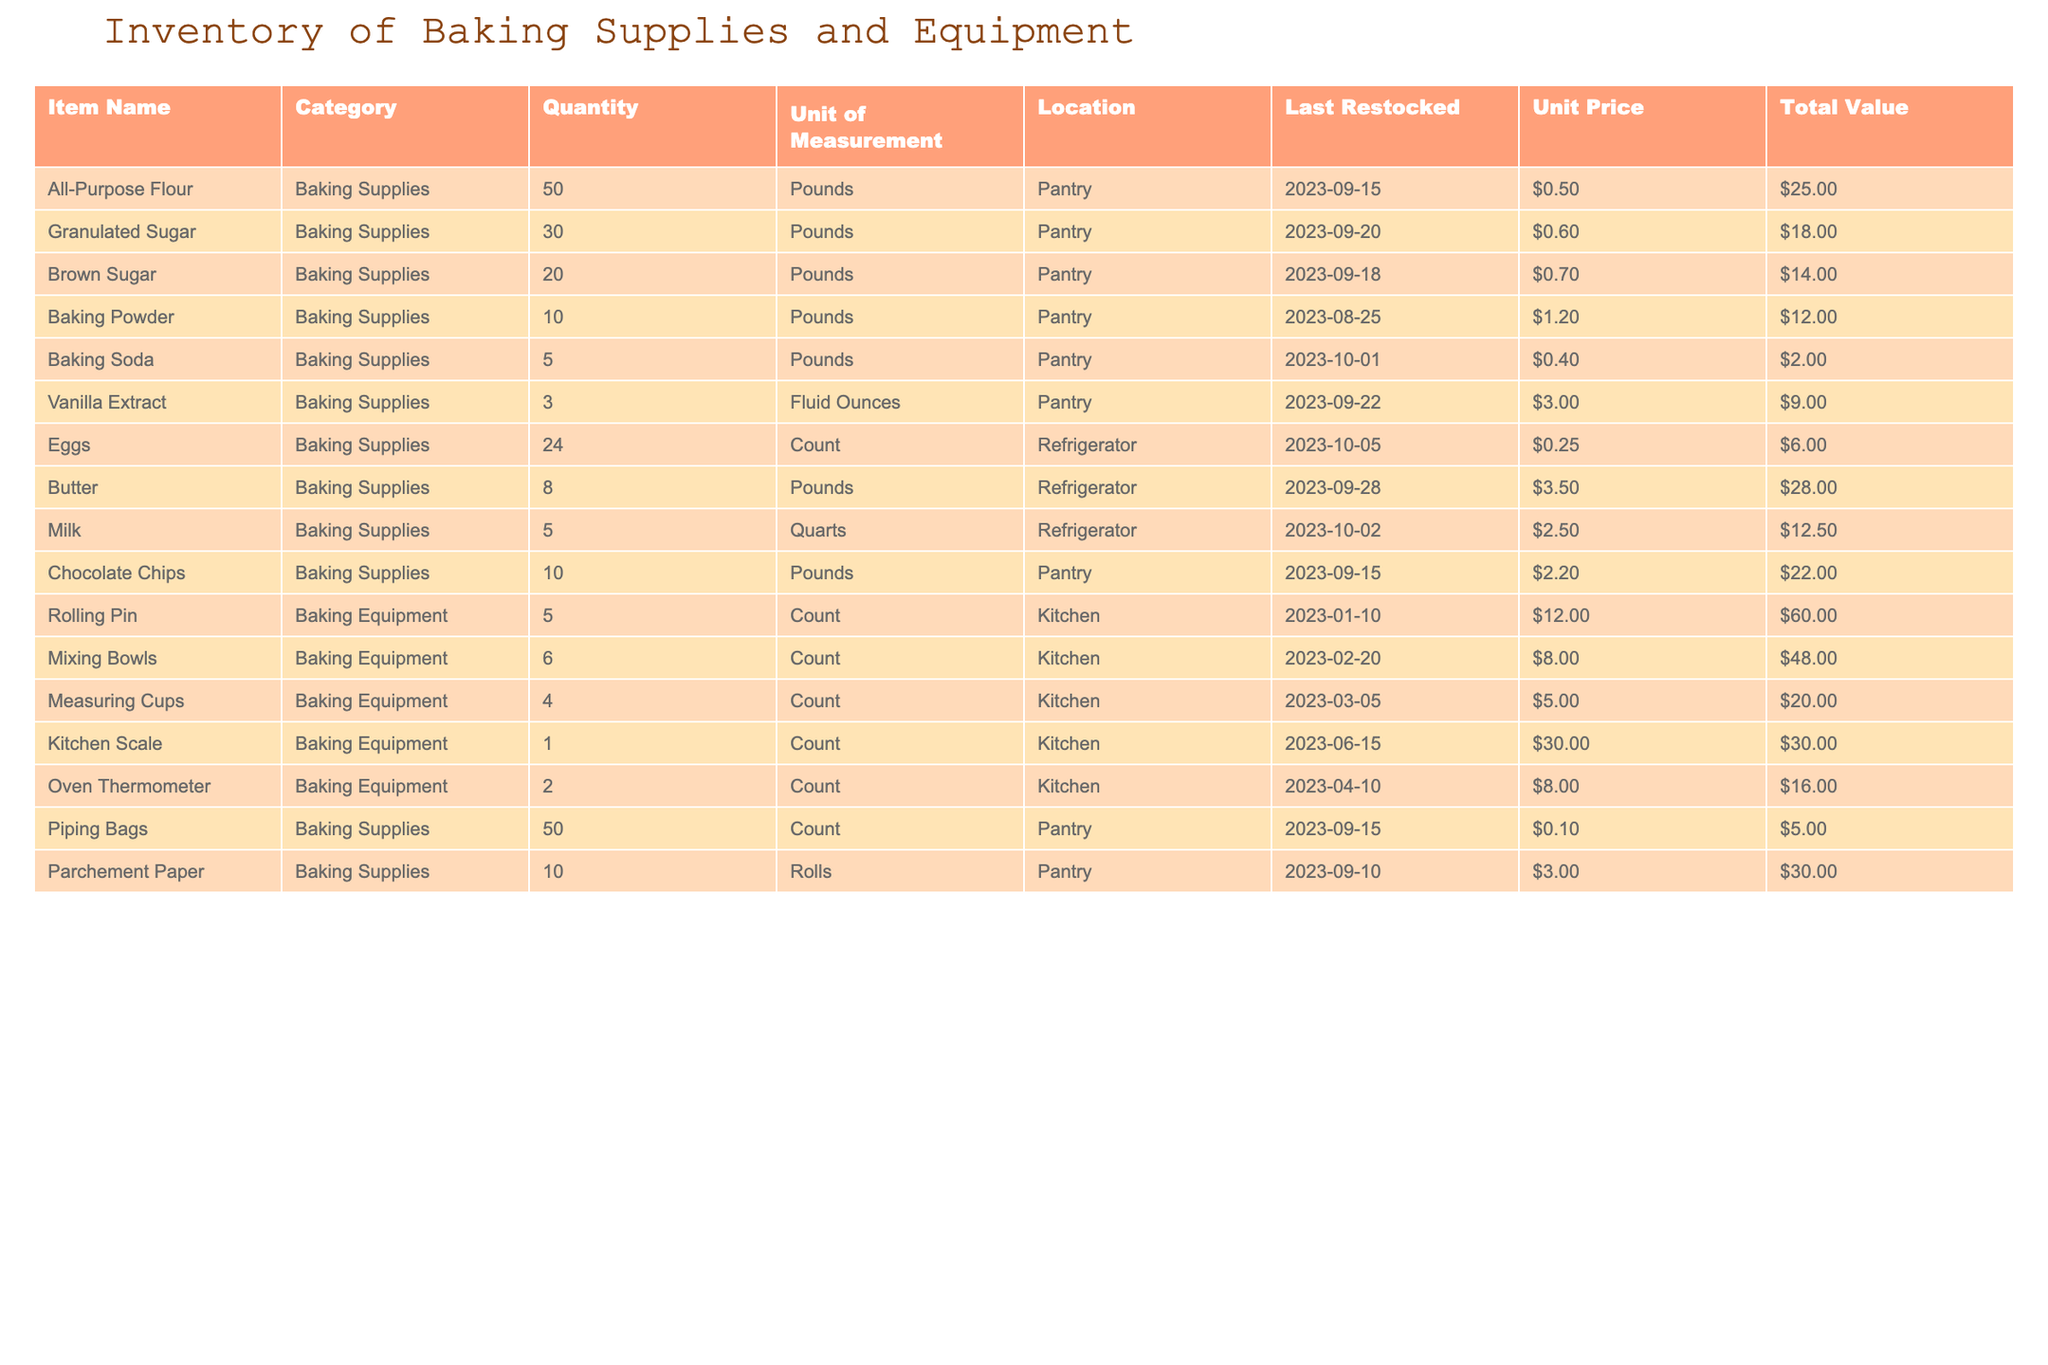What is the total quantity of Granulated Sugar in the inventory? The table lists the quantity of Granulated Sugar as 30 Pounds.
Answer: 30 Pounds How many different types of baking supplies are there? There are 11 items categorized as Baking Supplies.
Answer: 11 What is the total value of all the Eggs in the inventory? The total value of the Eggs is recorded as $6.00 based on the unit price of $0.25 and the quantity of 24.
Answer: $6.00 Is there more All-Purpose Flour than Chocolate Chips? Yes, the quantity of All-Purpose Flour is 50 Pounds, while that of Chocolate Chips is 10 Pounds.
Answer: Yes What is the average unit price of Baking Supplies based on the provided items? The sum of the unit prices for Baking Supplies is $0.50 + $0.60 + $0.70 + $1.20 + $0.40 + $3.00 + $0.25 + $3.50 + $2.50 + $2.20 = $14.35, and there are 10 items, thus the average is $14.35 / 10 = $1.44.
Answer: $1.44 How many units of Piping Bags are available in the inventory? The inventory shows that there are 50 Piping Bags.
Answer: 50 What is the difference between the total values of All-Purpose Flour and Brown Sugar? The total value of All-Purpose Flour is $25.00 and for Brown Sugar it is $14.00, so the difference is $25.00 - $14.00 = $11.00.
Answer: $11.00 Are there more Measuring Cups or Mixing Bowls in the inventory? There are 4 Measuring Cups and 6 Mixing Bowls, so there are more Mixing Bowls than Measuring Cups.
Answer: Mixing Bowls What is the last restock date for Baking Powder? The last restock date for Baking Powder is 2023-08-25.
Answer: 2023-08-25 What items have a quantity of less than 10 units? The items with a quantity of less than 10 units are Baking Soda (5 Pounds), Vanilla Extract (3 Fluid Ounces), Butter (8 Pounds), and Milk (5 Quarts).
Answer: Baking Soda, Vanilla Extract, Butter, Milk 